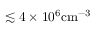Convert formula to latex. <formula><loc_0><loc_0><loc_500><loc_500>\lesssim 4 \times 1 0 ^ { 6 } c m ^ { - 3 }</formula> 